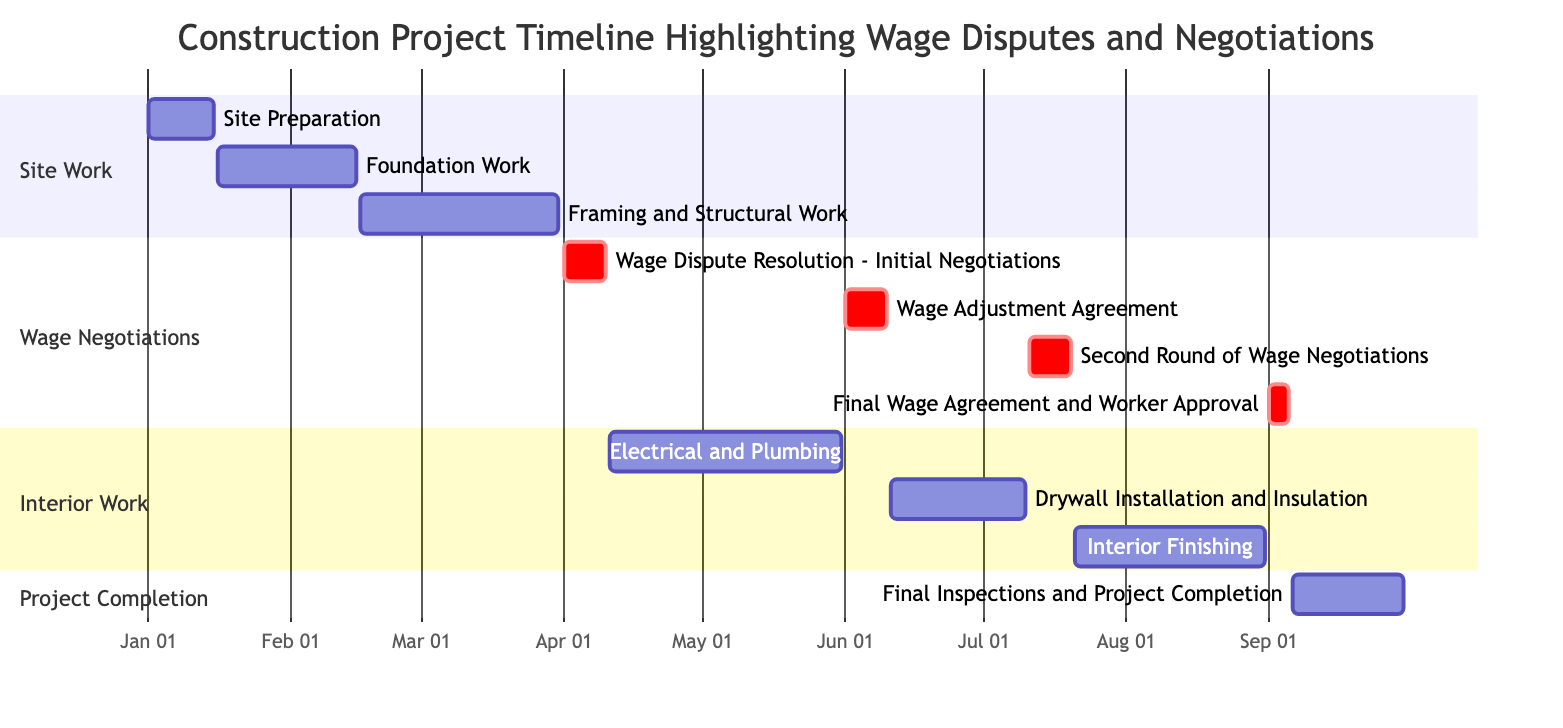What is the duration of the "Wage Dispute Resolution - Initial Negotiations" task? The task starts on April 1, 2023, and ends on April 10, 2023. The duration is calculated by subtracting the start date from the end date, which results in 10 days.
Answer: 10 days How many tasks are assigned to the "Site Work" section? The "Site Work" section contains three tasks: "Site Preparation," "Foundation Work," and "Framing and Structural Work." Counting these tasks gives a total of three in this section.
Answer: 3 What task follows "Electrical and Plumbing"? The task that immediately follows "Electrical and Plumbing," which ends on May 31, 2023, is "Drywall Installation and Insulation," beginning June 11, 2023.
Answer: Drywall Installation and Insulation Which tasks are part of the "Wage Negotiations" section? The tasks in the "Wage Negotiations" section are: "Wage Dispute Resolution - Initial Negotiations," "Wage Adjustment Agreement," "Second Round of Wage Negotiations," and "Final Wage Agreement and Worker Approval."
Answer: Wage Dispute Resolution - Initial Negotiations, Wage Adjustment Agreement, Second Round of Wage Negotiations, Final Wage Agreement and Worker Approval What are the start and end dates of the "Final Inspections and Project Completion" task? The "Final Inspections and Project Completion" task starts on September 6, 2023, and ends on September 30, 2023, as shown in the Gantt chart.
Answer: September 6, 2023 - September 30, 2023 When does the second round of wage negotiations occur? The second round of wage negotiations is scheduled from July 11, 2023, to July 20, 2023. By identifying the start and end date within the "Wage Negotiations" section, we get these dates.
Answer: July 11, 2023 - July 20, 2023 Which task has the longest duration? "Framing and Structural Work" lasts the longest from February 16, 2023, to March 31, 2023, totaling 44 days. This is determined by checking the duration of all tasks.
Answer: Framing and Structural Work How many tasks occur after the "Wage Adjustment Agreement"? After the "Wage Adjustment Agreement," which ends on June 10, 2023, there are two tasks: "Drywall Installation and Insulation" and "Second Round of Wage Negotiations." Counting these tasks gives a total of two.
Answer: 2 What is the time span between the first wage negotiation and the final wage agreement? The first wage negotiation starts on April 1, 2023, and the final wage agreement occurs from September 1, 2023, to September 5, 2023. The span from start to end is calculated from April 1, 2023, to September 5, 2023, totaling 127 days.
Answer: 127 days 